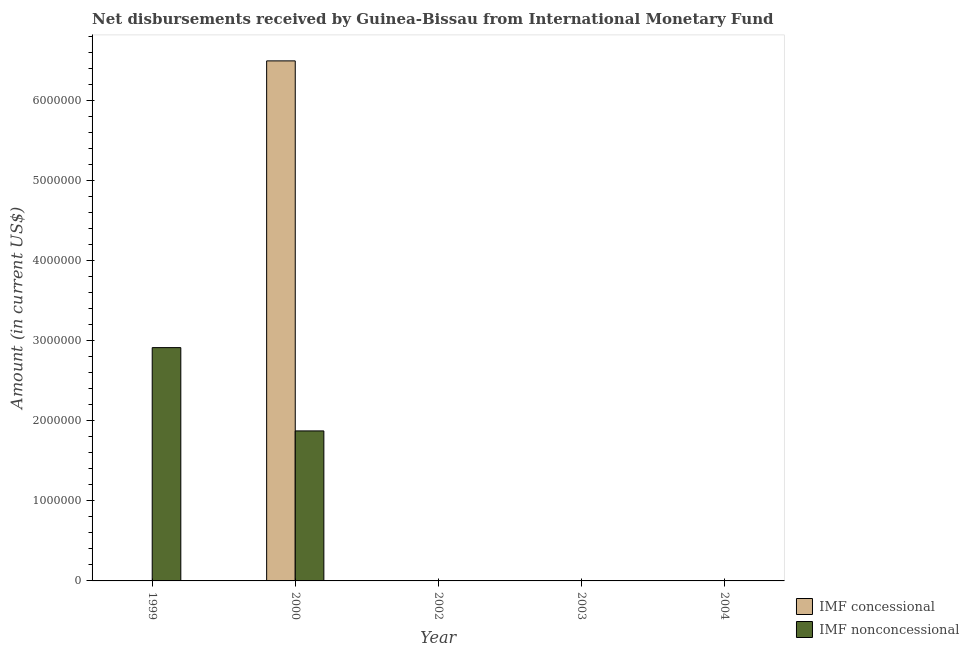How many different coloured bars are there?
Ensure brevity in your answer.  2. Are the number of bars per tick equal to the number of legend labels?
Your response must be concise. No. Are the number of bars on each tick of the X-axis equal?
Keep it short and to the point. No. How many bars are there on the 4th tick from the right?
Offer a very short reply. 2. What is the label of the 2nd group of bars from the left?
Provide a short and direct response. 2000. In how many cases, is the number of bars for a given year not equal to the number of legend labels?
Offer a very short reply. 4. What is the net non concessional disbursements from imf in 2004?
Ensure brevity in your answer.  0. Across all years, what is the maximum net concessional disbursements from imf?
Ensure brevity in your answer.  6.49e+06. Across all years, what is the minimum net non concessional disbursements from imf?
Give a very brief answer. 0. In which year was the net non concessional disbursements from imf maximum?
Offer a terse response. 1999. What is the total net concessional disbursements from imf in the graph?
Provide a short and direct response. 6.49e+06. What is the difference between the net non concessional disbursements from imf in 1999 and the net concessional disbursements from imf in 2003?
Make the answer very short. 2.91e+06. What is the average net concessional disbursements from imf per year?
Offer a very short reply. 1.30e+06. In how many years, is the net non concessional disbursements from imf greater than 1600000 US$?
Make the answer very short. 2. What is the ratio of the net non concessional disbursements from imf in 1999 to that in 2000?
Provide a succinct answer. 1.56. What is the difference between the highest and the lowest net non concessional disbursements from imf?
Your answer should be compact. 2.91e+06. In how many years, is the net non concessional disbursements from imf greater than the average net non concessional disbursements from imf taken over all years?
Provide a succinct answer. 2. Are all the bars in the graph horizontal?
Ensure brevity in your answer.  No. How many years are there in the graph?
Keep it short and to the point. 5. What is the difference between two consecutive major ticks on the Y-axis?
Provide a short and direct response. 1.00e+06. Are the values on the major ticks of Y-axis written in scientific E-notation?
Ensure brevity in your answer.  No. Does the graph contain any zero values?
Your answer should be compact. Yes. Does the graph contain grids?
Your answer should be very brief. No. Where does the legend appear in the graph?
Make the answer very short. Bottom right. How are the legend labels stacked?
Offer a terse response. Vertical. What is the title of the graph?
Keep it short and to the point. Net disbursements received by Guinea-Bissau from International Monetary Fund. Does "Working capital" appear as one of the legend labels in the graph?
Make the answer very short. No. What is the label or title of the Y-axis?
Your response must be concise. Amount (in current US$). What is the Amount (in current US$) of IMF nonconcessional in 1999?
Make the answer very short. 2.91e+06. What is the Amount (in current US$) in IMF concessional in 2000?
Provide a short and direct response. 6.49e+06. What is the Amount (in current US$) of IMF nonconcessional in 2000?
Provide a succinct answer. 1.87e+06. What is the Amount (in current US$) of IMF concessional in 2002?
Provide a succinct answer. 0. What is the Amount (in current US$) in IMF nonconcessional in 2003?
Offer a very short reply. 0. What is the Amount (in current US$) of IMF nonconcessional in 2004?
Your response must be concise. 0. Across all years, what is the maximum Amount (in current US$) in IMF concessional?
Provide a short and direct response. 6.49e+06. Across all years, what is the maximum Amount (in current US$) in IMF nonconcessional?
Keep it short and to the point. 2.91e+06. Across all years, what is the minimum Amount (in current US$) in IMF concessional?
Your answer should be very brief. 0. What is the total Amount (in current US$) in IMF concessional in the graph?
Ensure brevity in your answer.  6.49e+06. What is the total Amount (in current US$) in IMF nonconcessional in the graph?
Your response must be concise. 4.79e+06. What is the difference between the Amount (in current US$) in IMF nonconcessional in 1999 and that in 2000?
Offer a very short reply. 1.04e+06. What is the average Amount (in current US$) of IMF concessional per year?
Your response must be concise. 1.30e+06. What is the average Amount (in current US$) of IMF nonconcessional per year?
Give a very brief answer. 9.57e+05. In the year 2000, what is the difference between the Amount (in current US$) of IMF concessional and Amount (in current US$) of IMF nonconcessional?
Give a very brief answer. 4.62e+06. What is the ratio of the Amount (in current US$) of IMF nonconcessional in 1999 to that in 2000?
Provide a succinct answer. 1.56. What is the difference between the highest and the lowest Amount (in current US$) in IMF concessional?
Provide a succinct answer. 6.49e+06. What is the difference between the highest and the lowest Amount (in current US$) of IMF nonconcessional?
Give a very brief answer. 2.91e+06. 